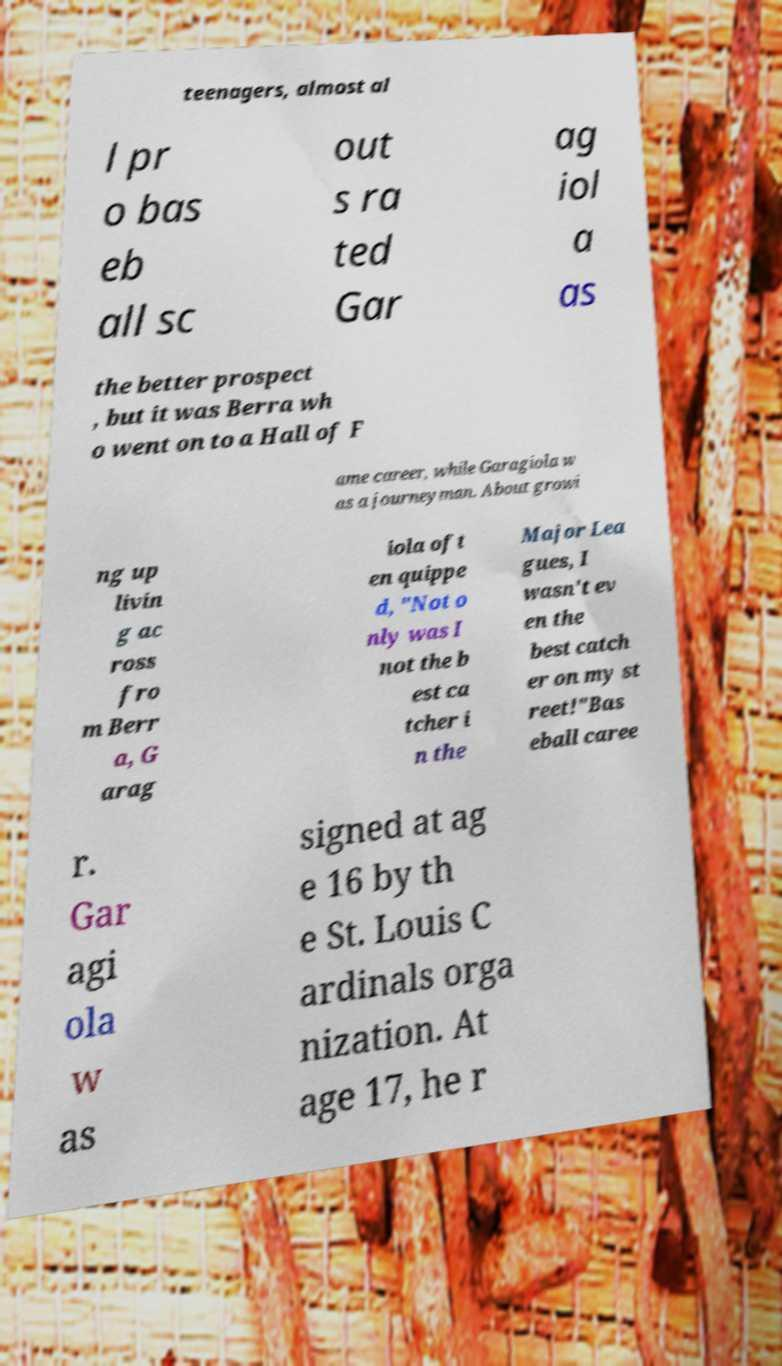There's text embedded in this image that I need extracted. Can you transcribe it verbatim? teenagers, almost al l pr o bas eb all sc out s ra ted Gar ag iol a as the better prospect , but it was Berra wh o went on to a Hall of F ame career, while Garagiola w as a journeyman. About growi ng up livin g ac ross fro m Berr a, G arag iola oft en quippe d, "Not o nly was I not the b est ca tcher i n the Major Lea gues, I wasn't ev en the best catch er on my st reet!"Bas eball caree r. Gar agi ola w as signed at ag e 16 by th e St. Louis C ardinals orga nization. At age 17, he r 